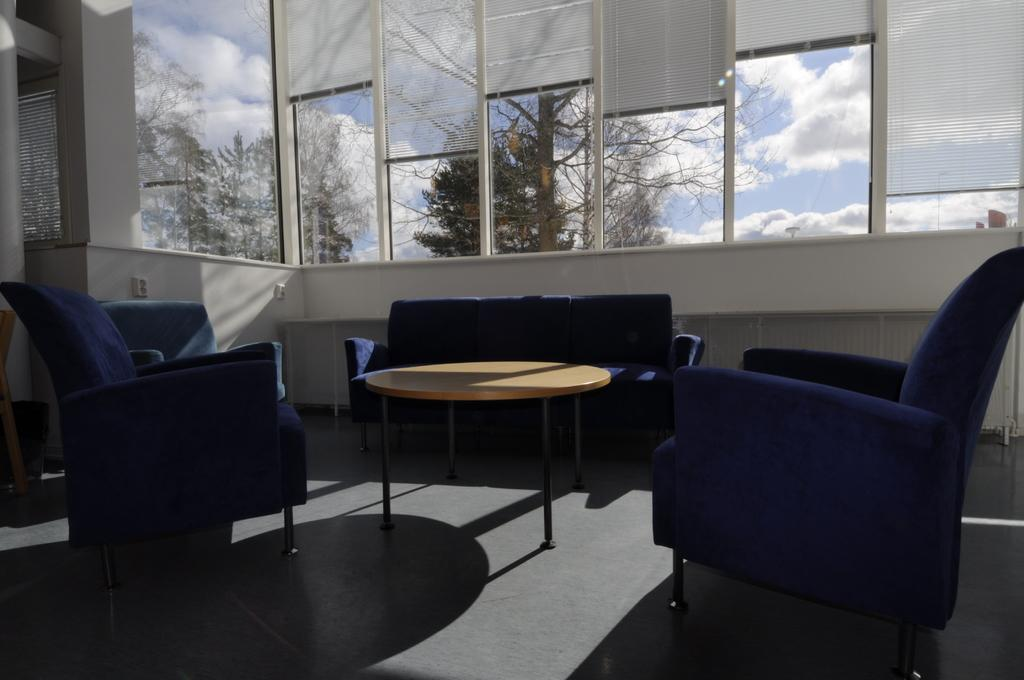What type of furniture is located in the middle of the room? There is a sofa set in the middle of the room. What type of room is depicted in the image? The room appears to be a living room. What can be seen in the background of the room? There is a window in the background of the room, and trees and the sky are visible outside the window. What is the condition of the sky outside the window? Clouds are present in the sky outside the window. What type of rod is hanging from the ceiling in the image? There is no rod hanging from the ceiling in the image. What color are the jeans worn by the person sitting on the sofa? There is no person sitting on the sofa in the image, so it is not possible to determine the color of their jeans. 